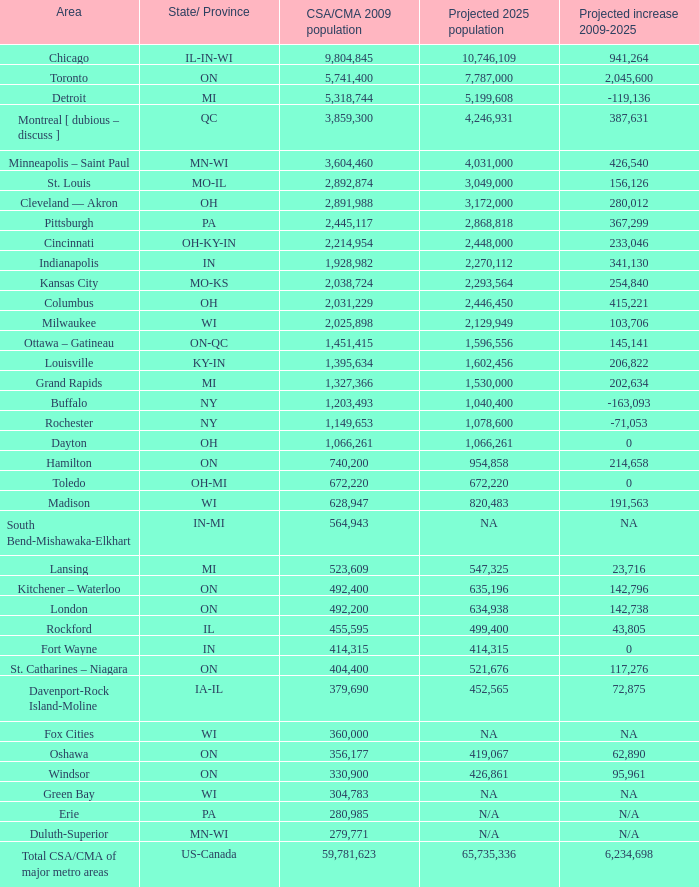What's the estimated population of in-mi? NA. 